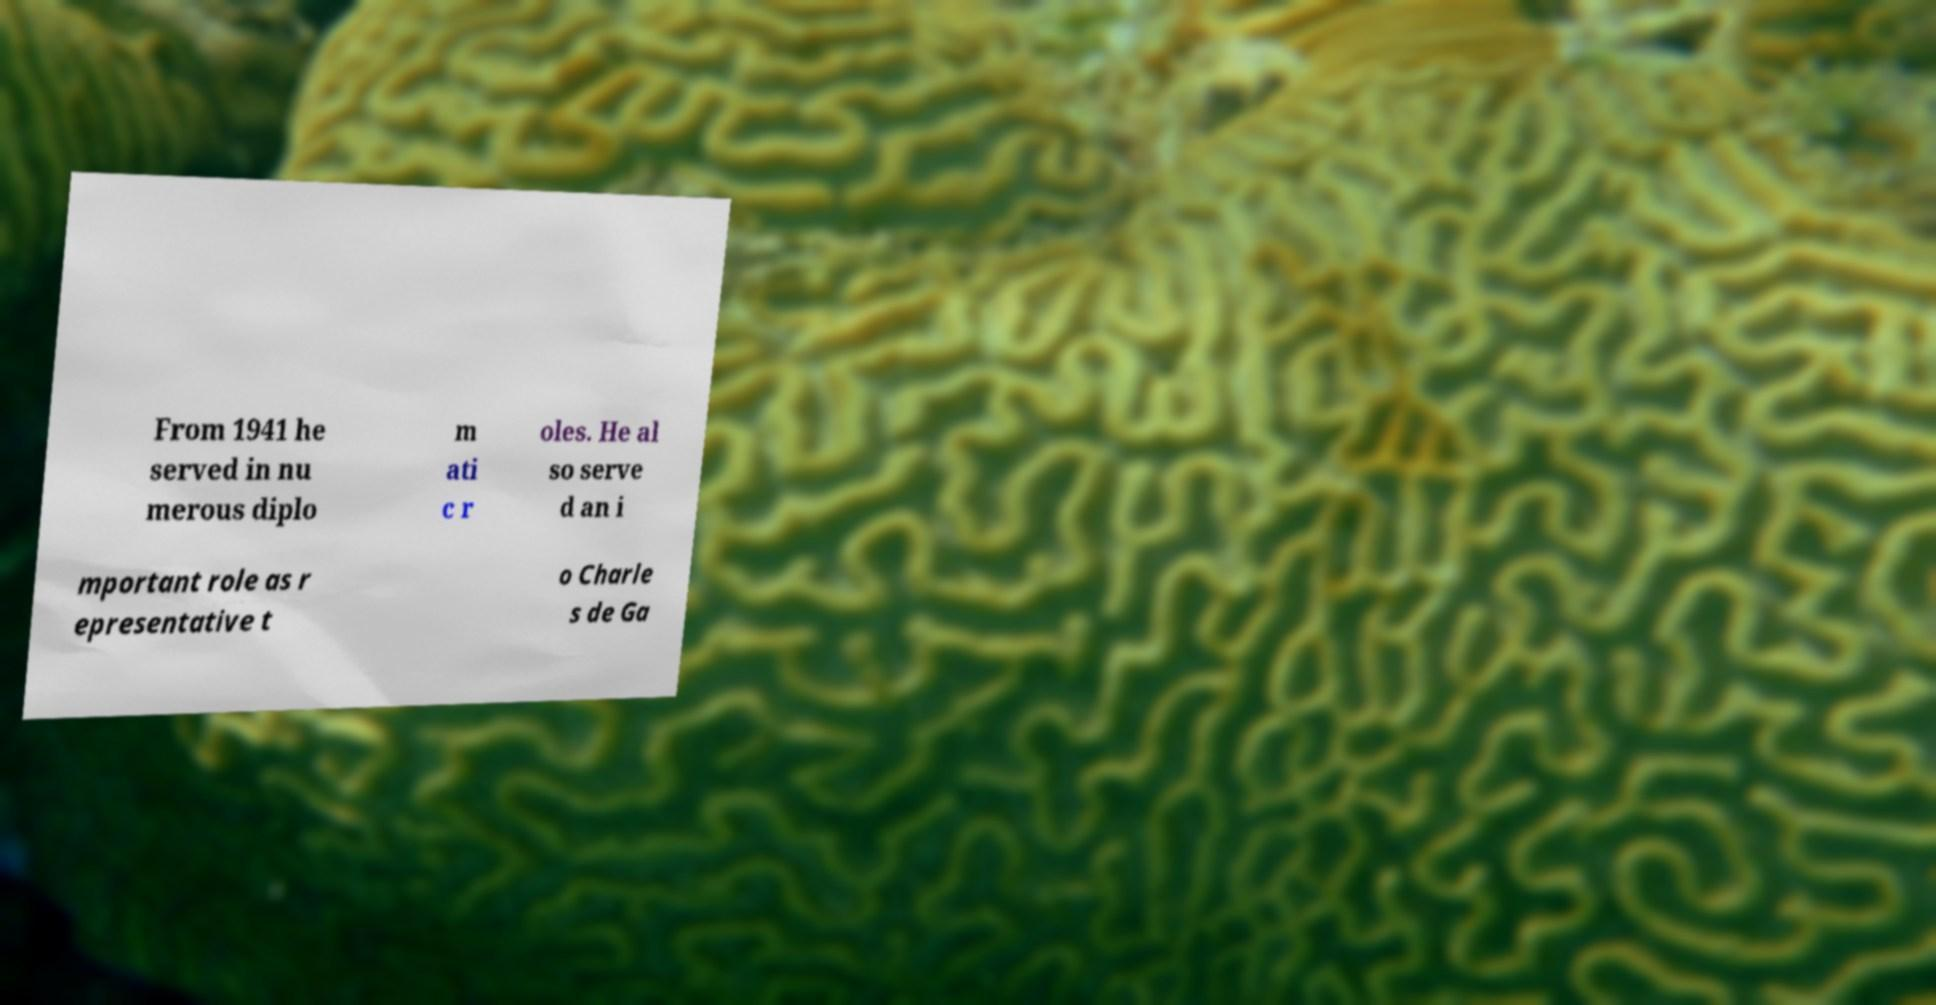Please read and relay the text visible in this image. What does it say? From 1941 he served in nu merous diplo m ati c r oles. He al so serve d an i mportant role as r epresentative t o Charle s de Ga 